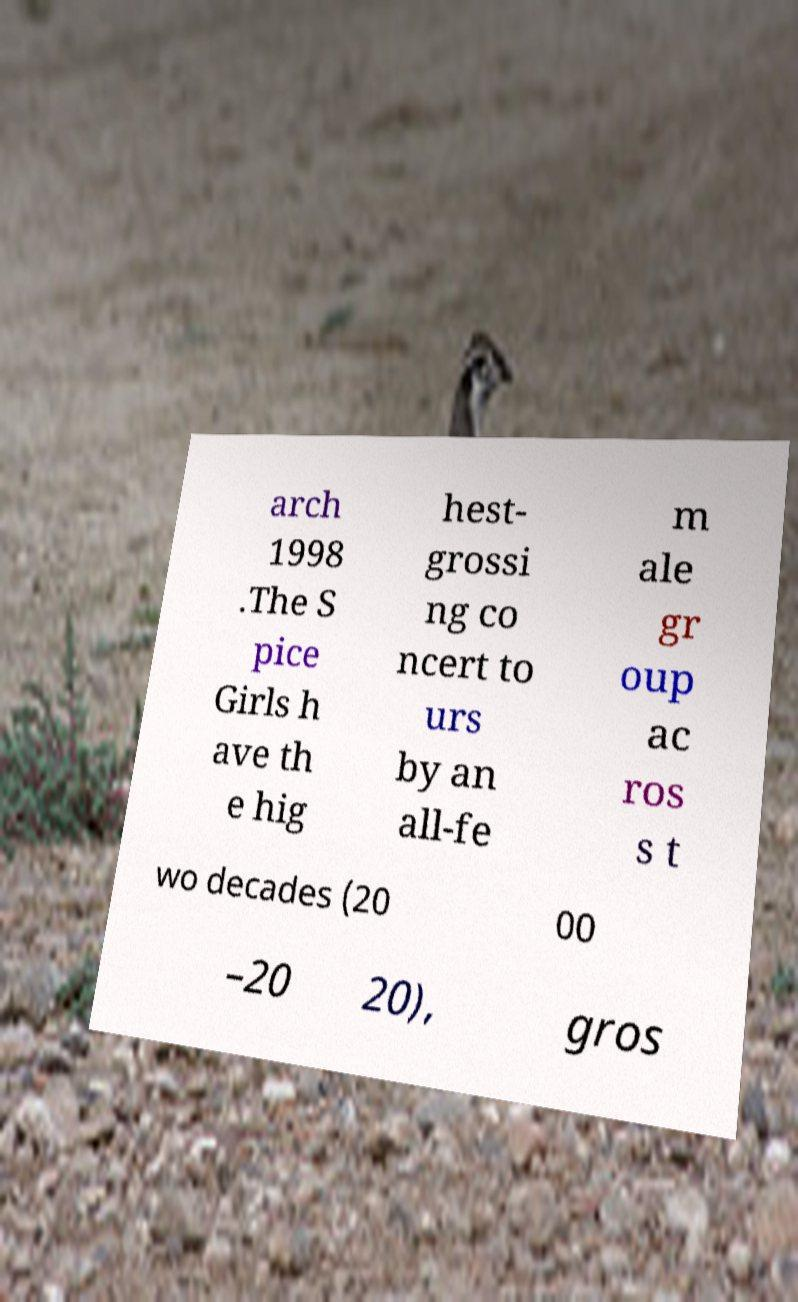Please read and relay the text visible in this image. What does it say? arch 1998 .The S pice Girls h ave th e hig hest- grossi ng co ncert to urs by an all-fe m ale gr oup ac ros s t wo decades (20 00 –20 20), gros 